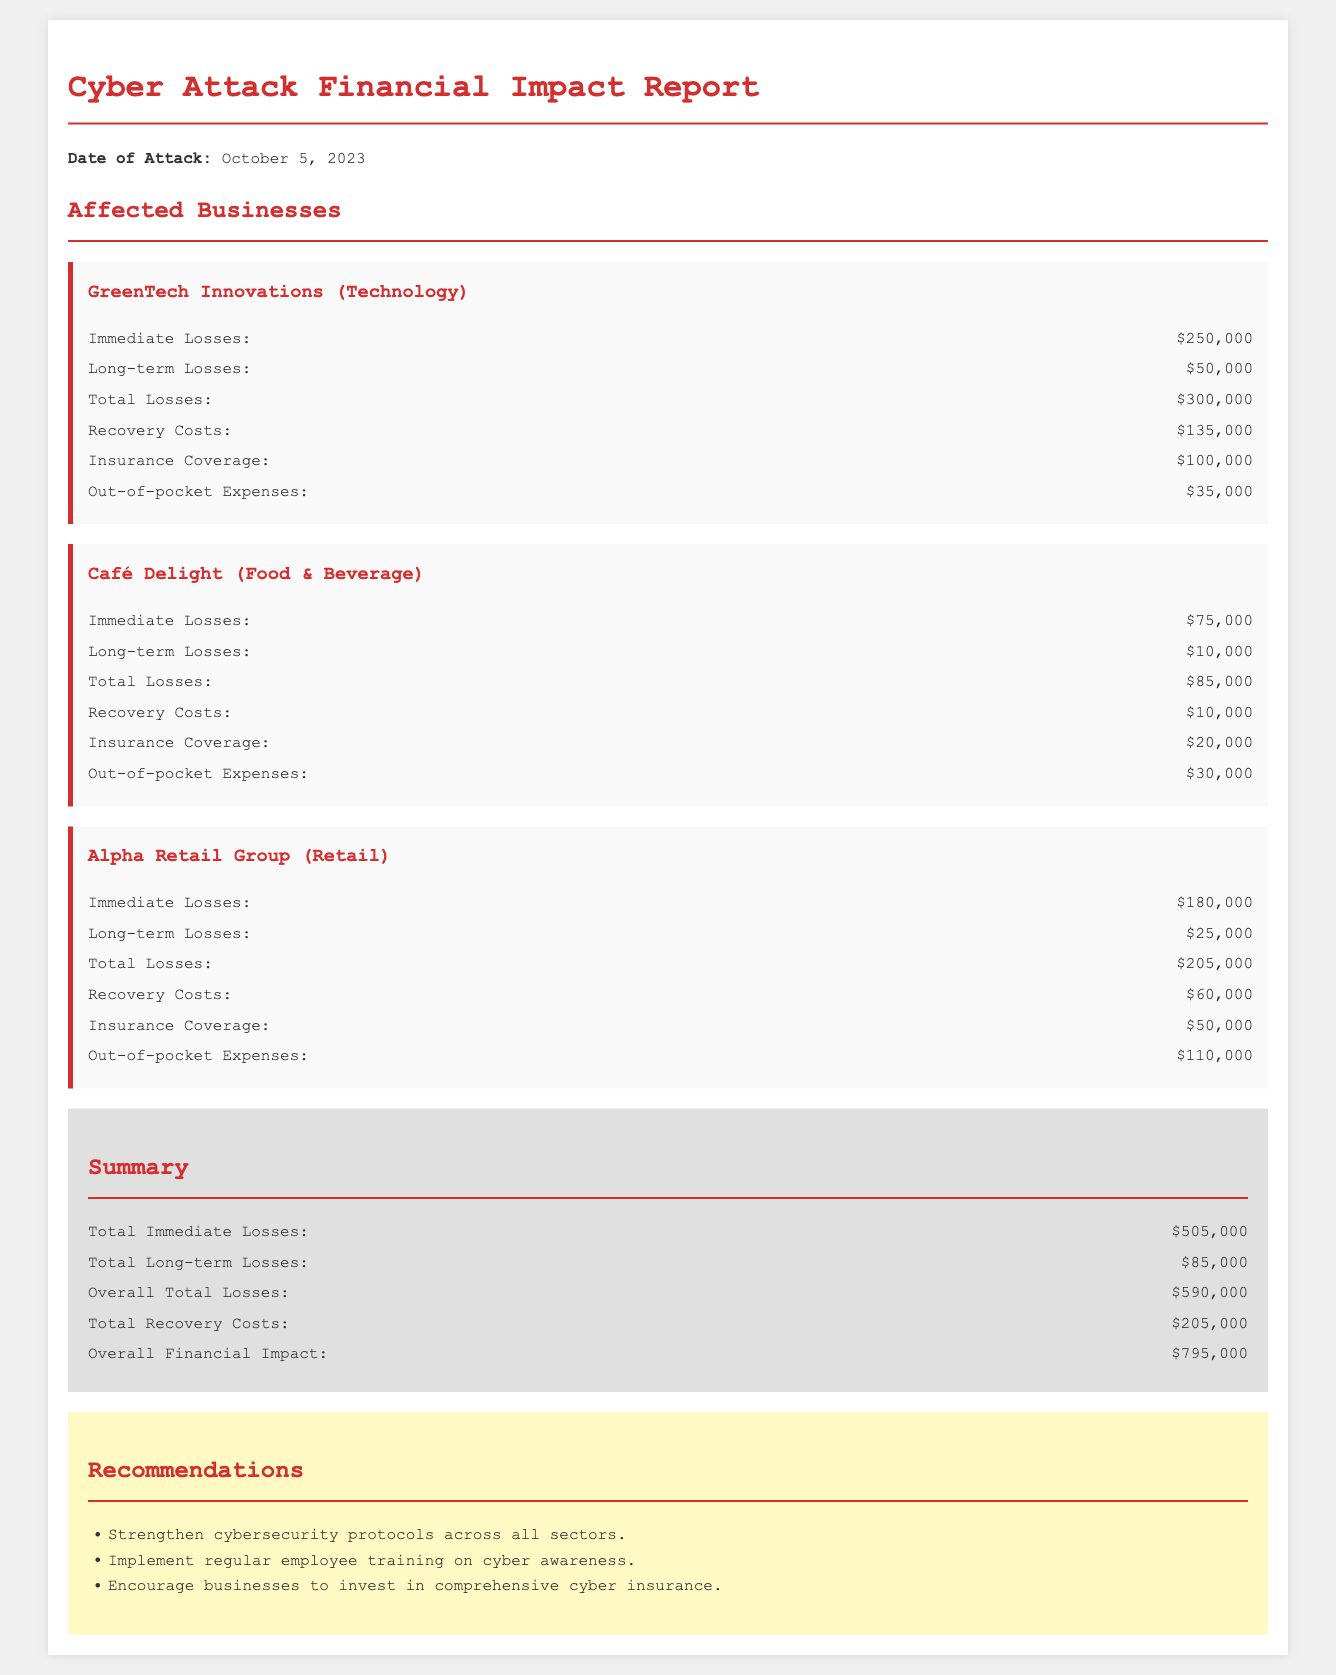What is the date of the attack? The date of the attack is stated prominently at the beginning of the report.
Answer: October 5, 2023 What are the total immediate losses for GreenTech Innovations? The total immediate losses for GreenTech Innovations are listed in the section for that company.
Answer: $250,000 What is the total recovery cost for Alpha Retail Group? The total recovery cost for Alpha Retail Group is specified in the data provided for that company.
Answer: $60,000 What is the overall total losses reported in the summary section? The overall total losses are summarized at the end of the report, reflecting the sum of all losses.
Answer: $590,000 How much insurance coverage does Café Delight have? The amount of insurance coverage for Café Delight is clearly mentioned in the relevant section for that company.
Answer: $20,000 What is the total financial impact of the cyber attack? The total financial impact of the cyber attack is calculated and presented in the summary section of the report.
Answer: $795,000 Which company experienced the highest immediate losses? The company with the highest immediate losses can be determined by comparing the losses listed for each company.
Answer: GreenTech Innovations What is one of the recommendations given in the report? The recommendations section lists strategies for improving cybersecurity, providing actionable advice following the attack.
Answer: Strengthen cybersecurity protocols across all sectors 